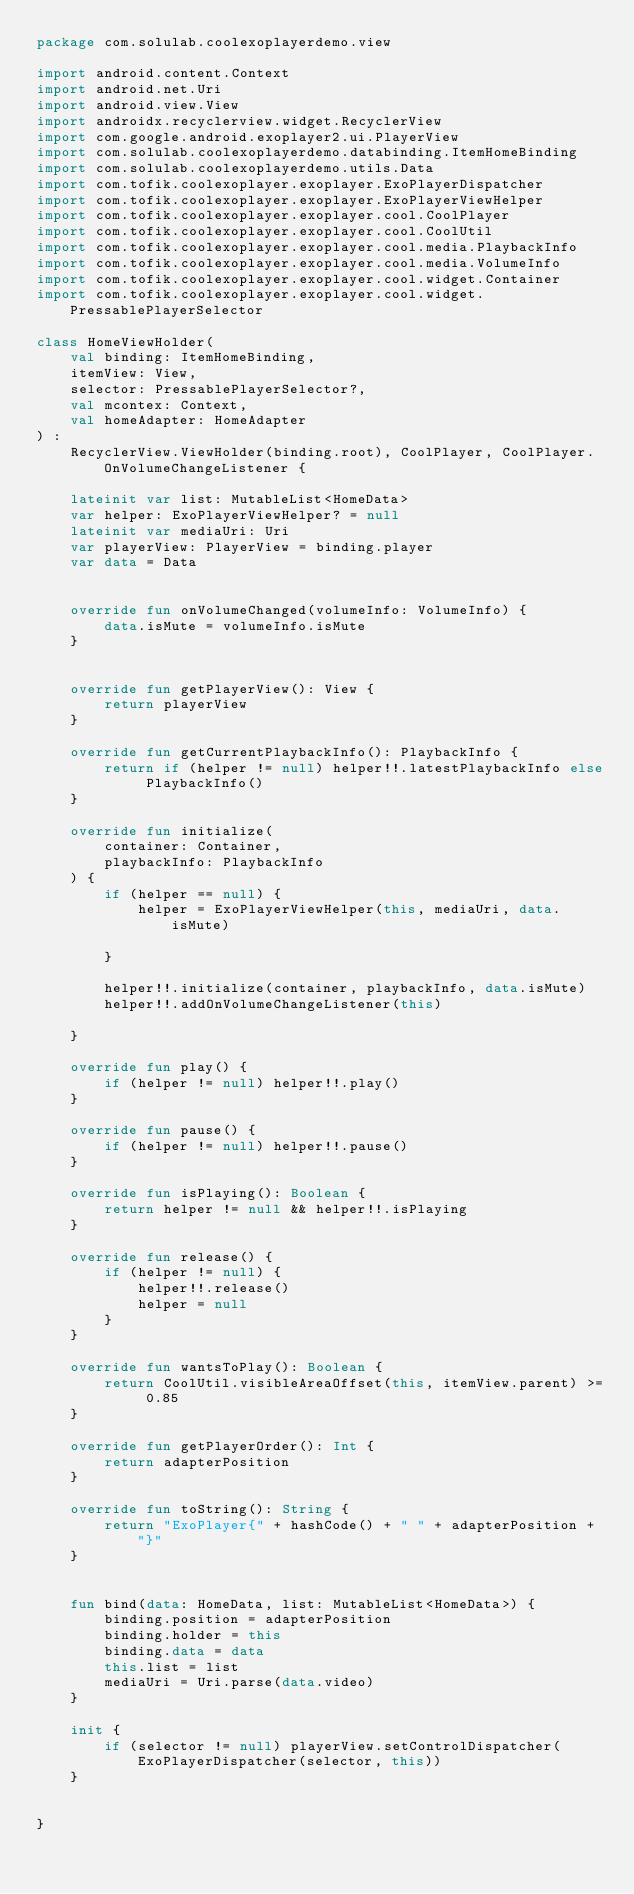Convert code to text. <code><loc_0><loc_0><loc_500><loc_500><_Kotlin_>package com.solulab.coolexoplayerdemo.view

import android.content.Context
import android.net.Uri
import android.view.View
import androidx.recyclerview.widget.RecyclerView
import com.google.android.exoplayer2.ui.PlayerView
import com.solulab.coolexoplayerdemo.databinding.ItemHomeBinding
import com.solulab.coolexoplayerdemo.utils.Data
import com.tofik.coolexoplayer.exoplayer.ExoPlayerDispatcher
import com.tofik.coolexoplayer.exoplayer.ExoPlayerViewHelper
import com.tofik.coolexoplayer.exoplayer.cool.CoolPlayer
import com.tofik.coolexoplayer.exoplayer.cool.CoolUtil
import com.tofik.coolexoplayer.exoplayer.cool.media.PlaybackInfo
import com.tofik.coolexoplayer.exoplayer.cool.media.VolumeInfo
import com.tofik.coolexoplayer.exoplayer.cool.widget.Container
import com.tofik.coolexoplayer.exoplayer.cool.widget.PressablePlayerSelector

class HomeViewHolder(
    val binding: ItemHomeBinding,
    itemView: View,
    selector: PressablePlayerSelector?,
    val mcontex: Context,
    val homeAdapter: HomeAdapter
) :
    RecyclerView.ViewHolder(binding.root), CoolPlayer, CoolPlayer.OnVolumeChangeListener {

    lateinit var list: MutableList<HomeData>
    var helper: ExoPlayerViewHelper? = null
    lateinit var mediaUri: Uri
    var playerView: PlayerView = binding.player
    var data = Data


    override fun onVolumeChanged(volumeInfo: VolumeInfo) {
        data.isMute = volumeInfo.isMute
    }


    override fun getPlayerView(): View {
        return playerView
    }

    override fun getCurrentPlaybackInfo(): PlaybackInfo {
        return if (helper != null) helper!!.latestPlaybackInfo else PlaybackInfo()
    }

    override fun initialize(
        container: Container,
        playbackInfo: PlaybackInfo
    ) {
        if (helper == null) {
            helper = ExoPlayerViewHelper(this, mediaUri, data.isMute)

        }

        helper!!.initialize(container, playbackInfo, data.isMute)
        helper!!.addOnVolumeChangeListener(this)

    }

    override fun play() {
        if (helper != null) helper!!.play()
    }

    override fun pause() {
        if (helper != null) helper!!.pause()
    }

    override fun isPlaying(): Boolean {
        return helper != null && helper!!.isPlaying
    }

    override fun release() {
        if (helper != null) {
            helper!!.release()
            helper = null
        }
    }

    override fun wantsToPlay(): Boolean {
        return CoolUtil.visibleAreaOffset(this, itemView.parent) >= 0.85
    }

    override fun getPlayerOrder(): Int {
        return adapterPosition
    }

    override fun toString(): String {
        return "ExoPlayer{" + hashCode() + " " + adapterPosition + "}"
    }


    fun bind(data: HomeData, list: MutableList<HomeData>) {
        binding.position = adapterPosition
        binding.holder = this
        binding.data = data
        this.list = list
        mediaUri = Uri.parse(data.video)
    }

    init {
        if (selector != null) playerView.setControlDispatcher(ExoPlayerDispatcher(selector, this))
    }


}
</code> 